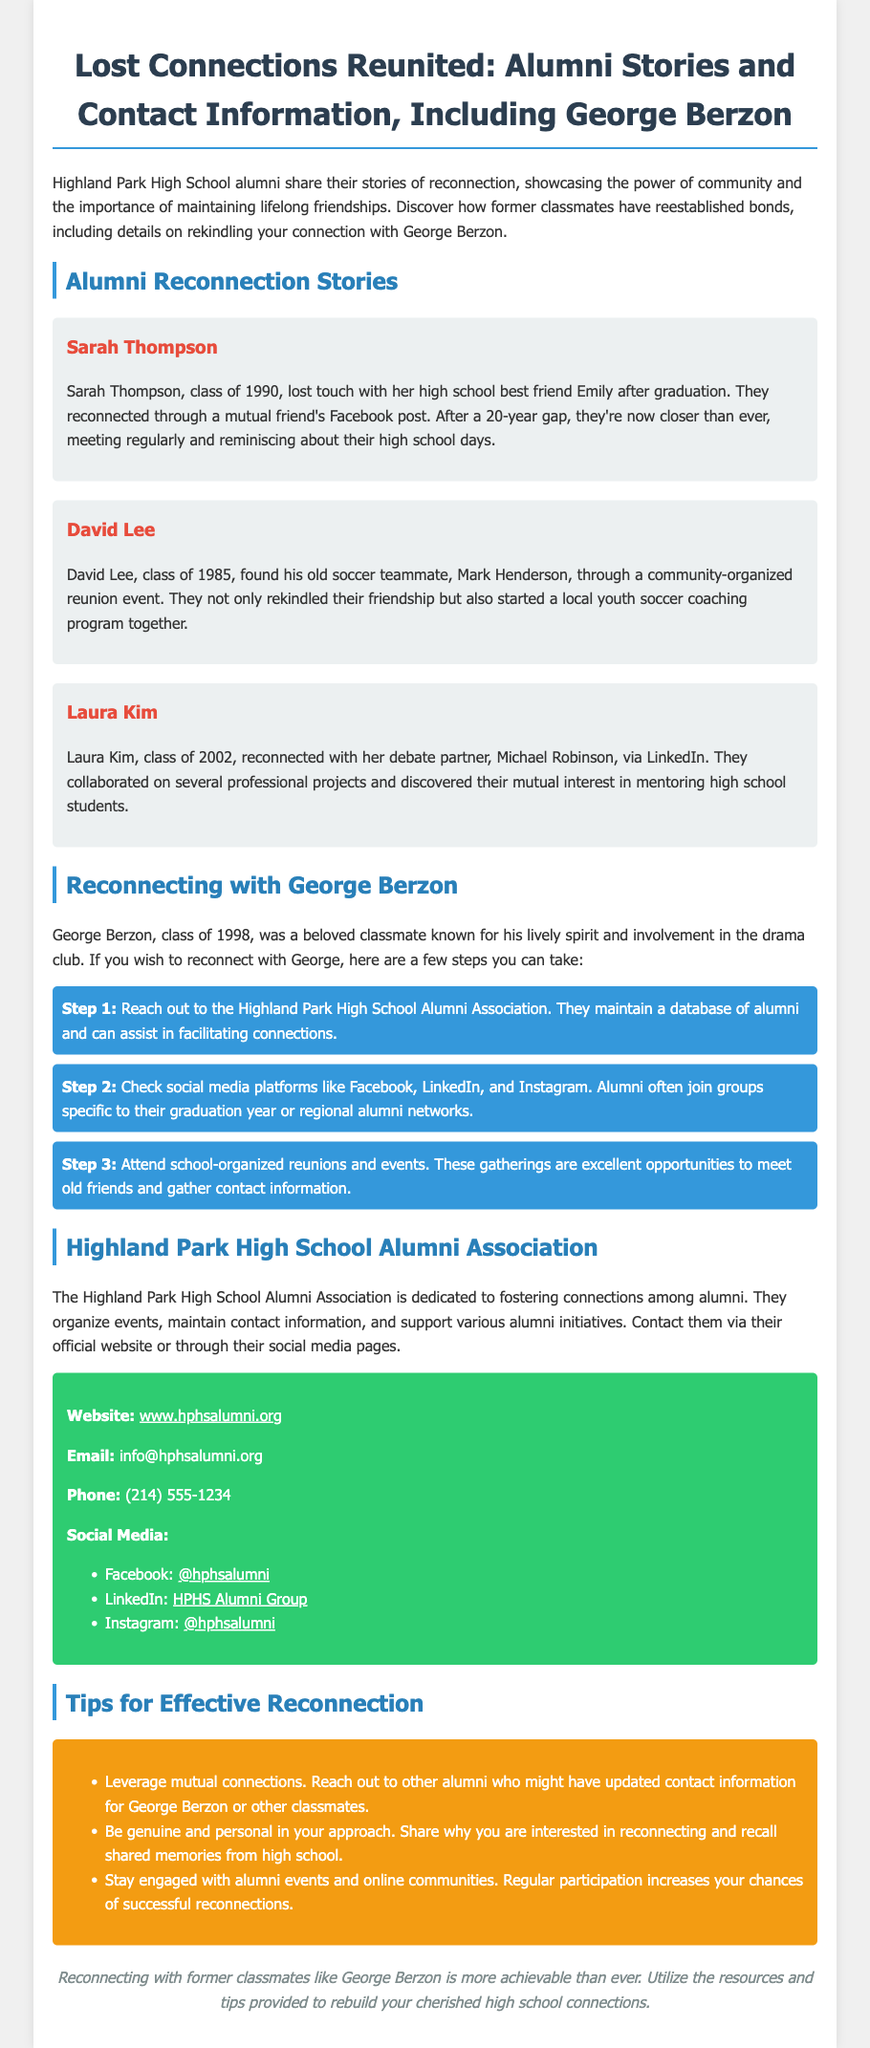What is the title of the document? The title of the document is stated in the header and introduces the subject matter, which is the reunion of alumni stories and contact information.
Answer: Lost Connections Reunited: Alumni Stories and Contact Information, Including George Berzon Who is a featured alum from the class of 1990? The document mentions several alumni, including Sarah Thompson, who is from the class of 1990 and shares her story of reconnection.
Answer: Sarah Thompson What social media platforms are suggested for reconnecting? The document lists platforms where alumni can reconnect, specifically mentioning Facebook, LinkedIn, and Instagram.
Answer: Facebook, LinkedIn, Instagram What year did George Berzon graduate? The text provides the graduation year of George Berzon in a specific section about reconnecting with him.
Answer: 1998 How can you contact the Highland Park High School Alumni Association by phone? The document provides a specific phone number for contacting the Alumni Association, which is mentioned in the contact information section.
Answer: (214) 555-1234 How many steps are suggested to reconnect with George Berzon? The document outlines a specific number of steps to take for reconnecting with George Berzon, which are organized as a list.
Answer: 3 What is one tip for effective reconnection mentioned in the document? The text lists several tips under a specific section dedicated to effective reconnection, one of which is to leverage mutual connections.
Answer: Leverage mutual connections What is the color of the background used in the contact info section? The document describes the background color of the contact information section, which is distinct from other sections.
Answer: Green 